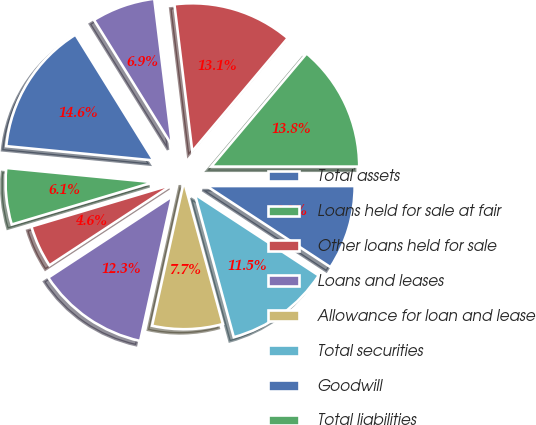<chart> <loc_0><loc_0><loc_500><loc_500><pie_chart><fcel>Total assets<fcel>Loans held for sale at fair<fcel>Other loans held for sale<fcel>Loans and leases<fcel>Allowance for loan and lease<fcel>Total securities<fcel>Goodwill<fcel>Total liabilities<fcel>Total deposits (6)<fcel>Federal funds purchased and<nl><fcel>14.62%<fcel>6.15%<fcel>4.62%<fcel>12.31%<fcel>7.69%<fcel>11.54%<fcel>9.23%<fcel>13.85%<fcel>13.08%<fcel>6.92%<nl></chart> 